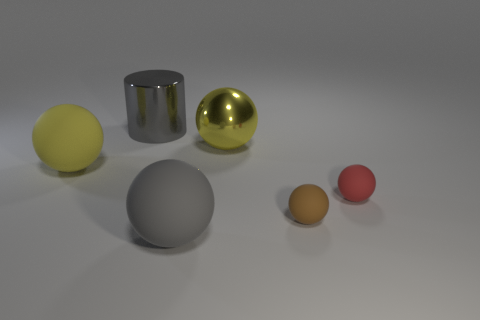Can you explain the arrangement and possible meaning behind the placement of these spheres? While the arrangement of the spheres might not have an explicit meaning, it can be interpreted in various ways. Visually, the spheres are arranged by size in a descending order from left to right, which creates a sense of balance and harmony in the composition. Metaphorically, one could view this as a representation of order, hierarchy, or the passage of time with the diminishing sizes implying progression or reduction. The variety in textures and finishes may also be conveying the diversity of elements in a harmonious system. 